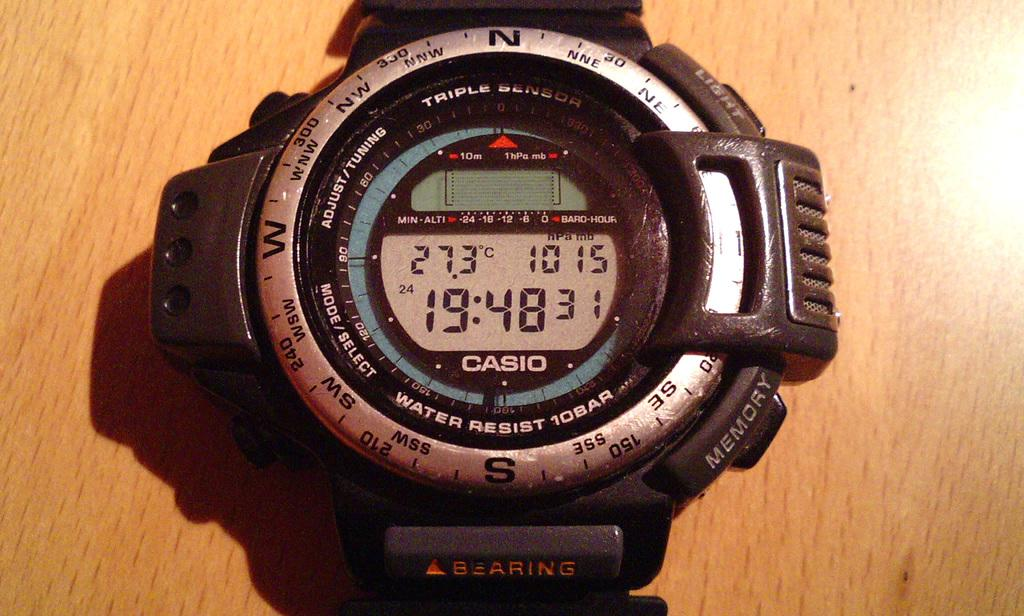<image>
Summarize the visual content of the image. the time is 19:48 that is on a clock 